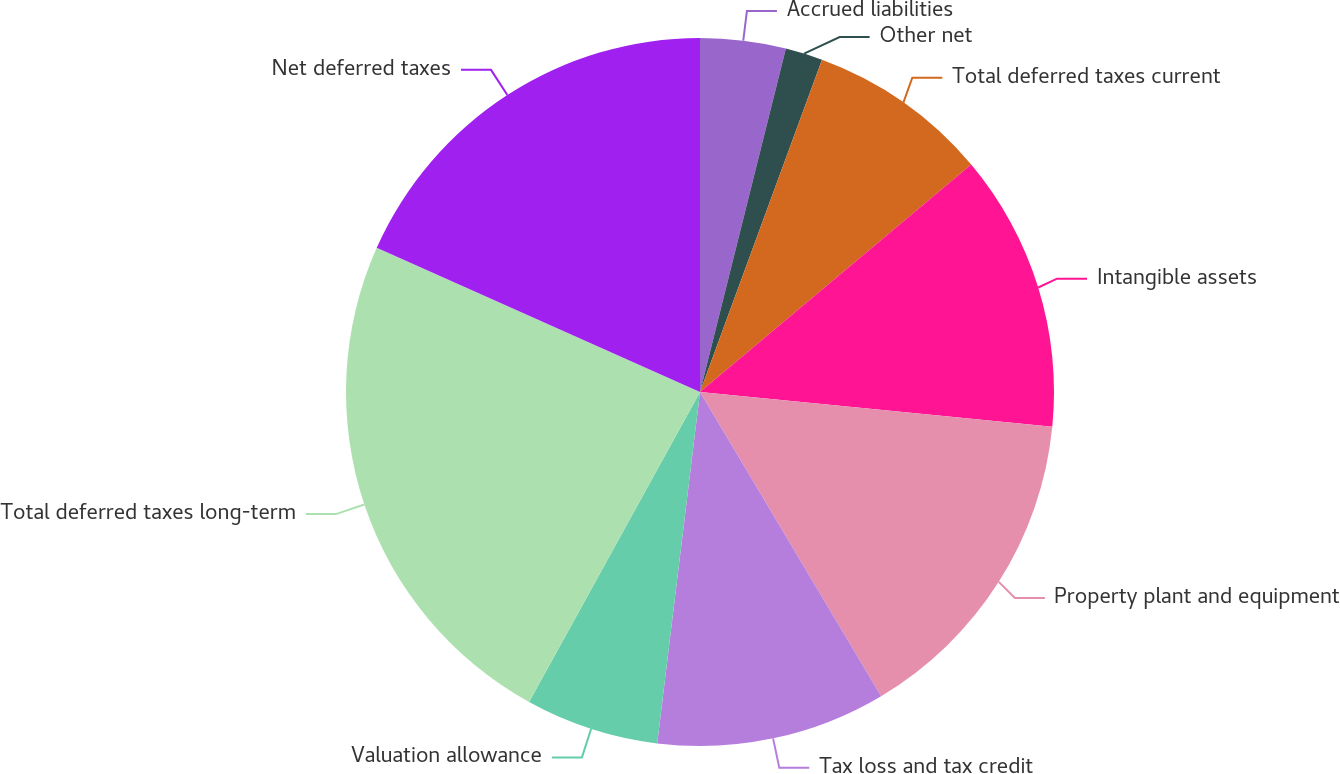<chart> <loc_0><loc_0><loc_500><loc_500><pie_chart><fcel>Accrued liabilities<fcel>Other net<fcel>Total deferred taxes current<fcel>Intangible assets<fcel>Property plant and equipment<fcel>Tax loss and tax credit<fcel>Valuation allowance<fcel>Total deferred taxes long-term<fcel>Net deferred taxes<nl><fcel>3.9%<fcel>1.7%<fcel>8.29%<fcel>12.68%<fcel>14.88%<fcel>10.48%<fcel>6.09%<fcel>23.66%<fcel>18.32%<nl></chart> 